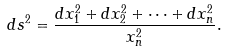<formula> <loc_0><loc_0><loc_500><loc_500>d s ^ { 2 } = \frac { d x _ { 1 } ^ { 2 } + d x _ { 2 } ^ { 2 } + \dots + d x _ { n } ^ { 2 } } { x _ { n } ^ { 2 } } .</formula> 